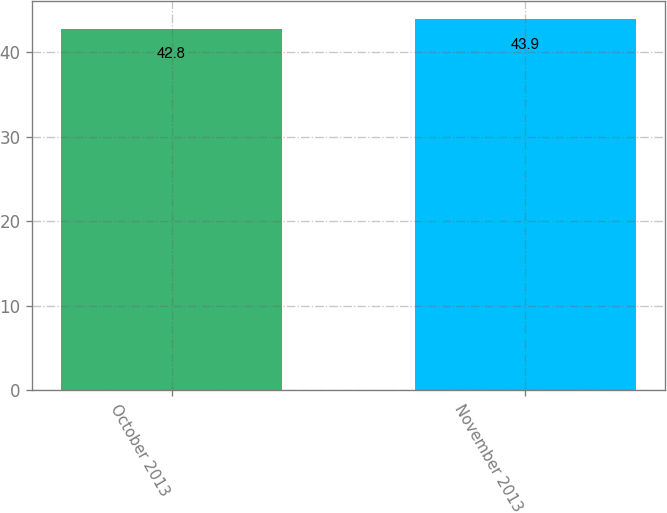Convert chart to OTSL. <chart><loc_0><loc_0><loc_500><loc_500><bar_chart><fcel>October 2013<fcel>November 2013<nl><fcel>42.8<fcel>43.9<nl></chart> 